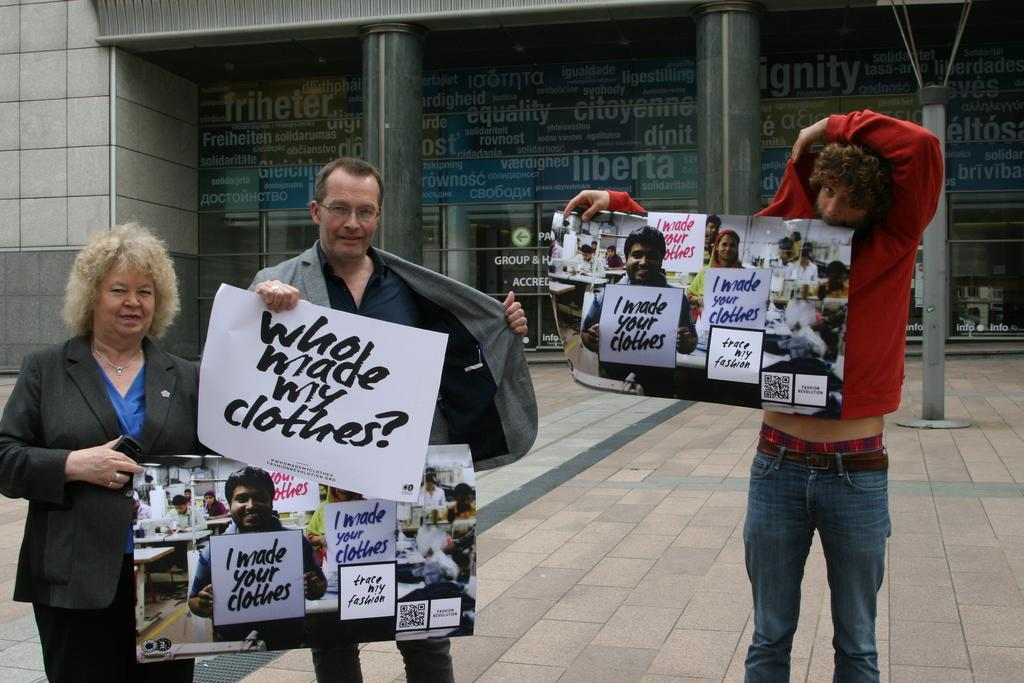How many people are in the image? There are three people in the image. What are the people doing in the image? The people are standing and holding posters. What can be seen on the posters? The posters have images and text on them. What is visible in the background of the image? There is a building in the background of the image. What type of substance can be seen flowing from the top of the building in the image? There is no substance flowing from the top of the building in the image. Is there an island visible in the image? No, there is no island present in the image. 